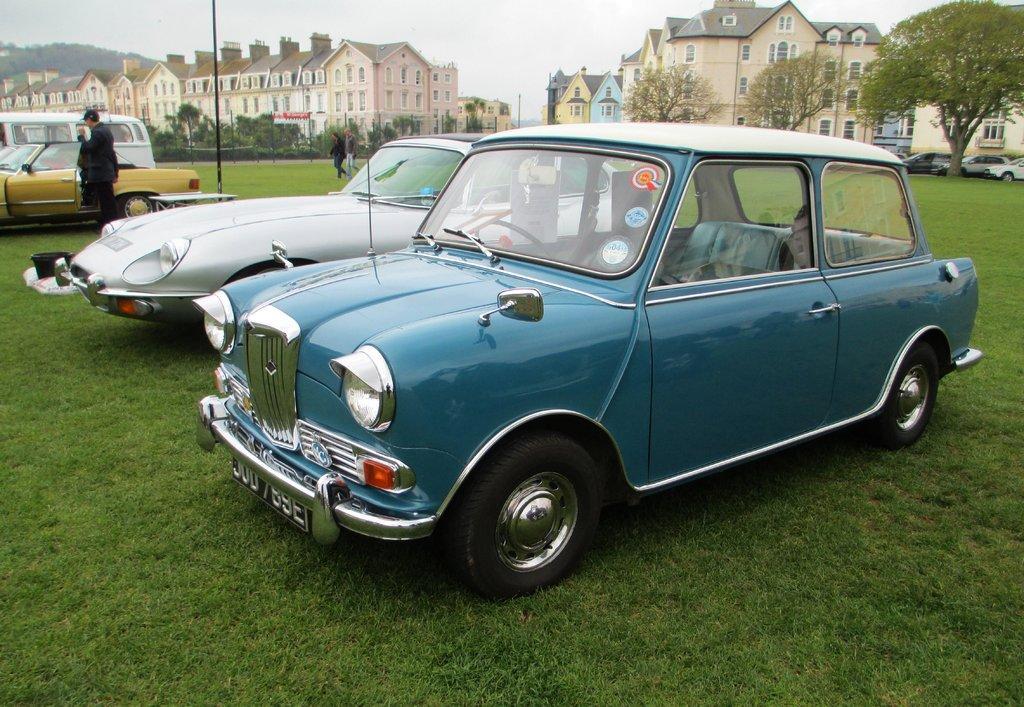In one or two sentences, can you explain what this image depicts? This is an outside view. Here I can see few cars on the ground. On the left side there is a person standing beside the car and there are two persons walking. On the ground, I can see the grass. In the background there are many trees and buildings. At the top of the image I can see the sky. 